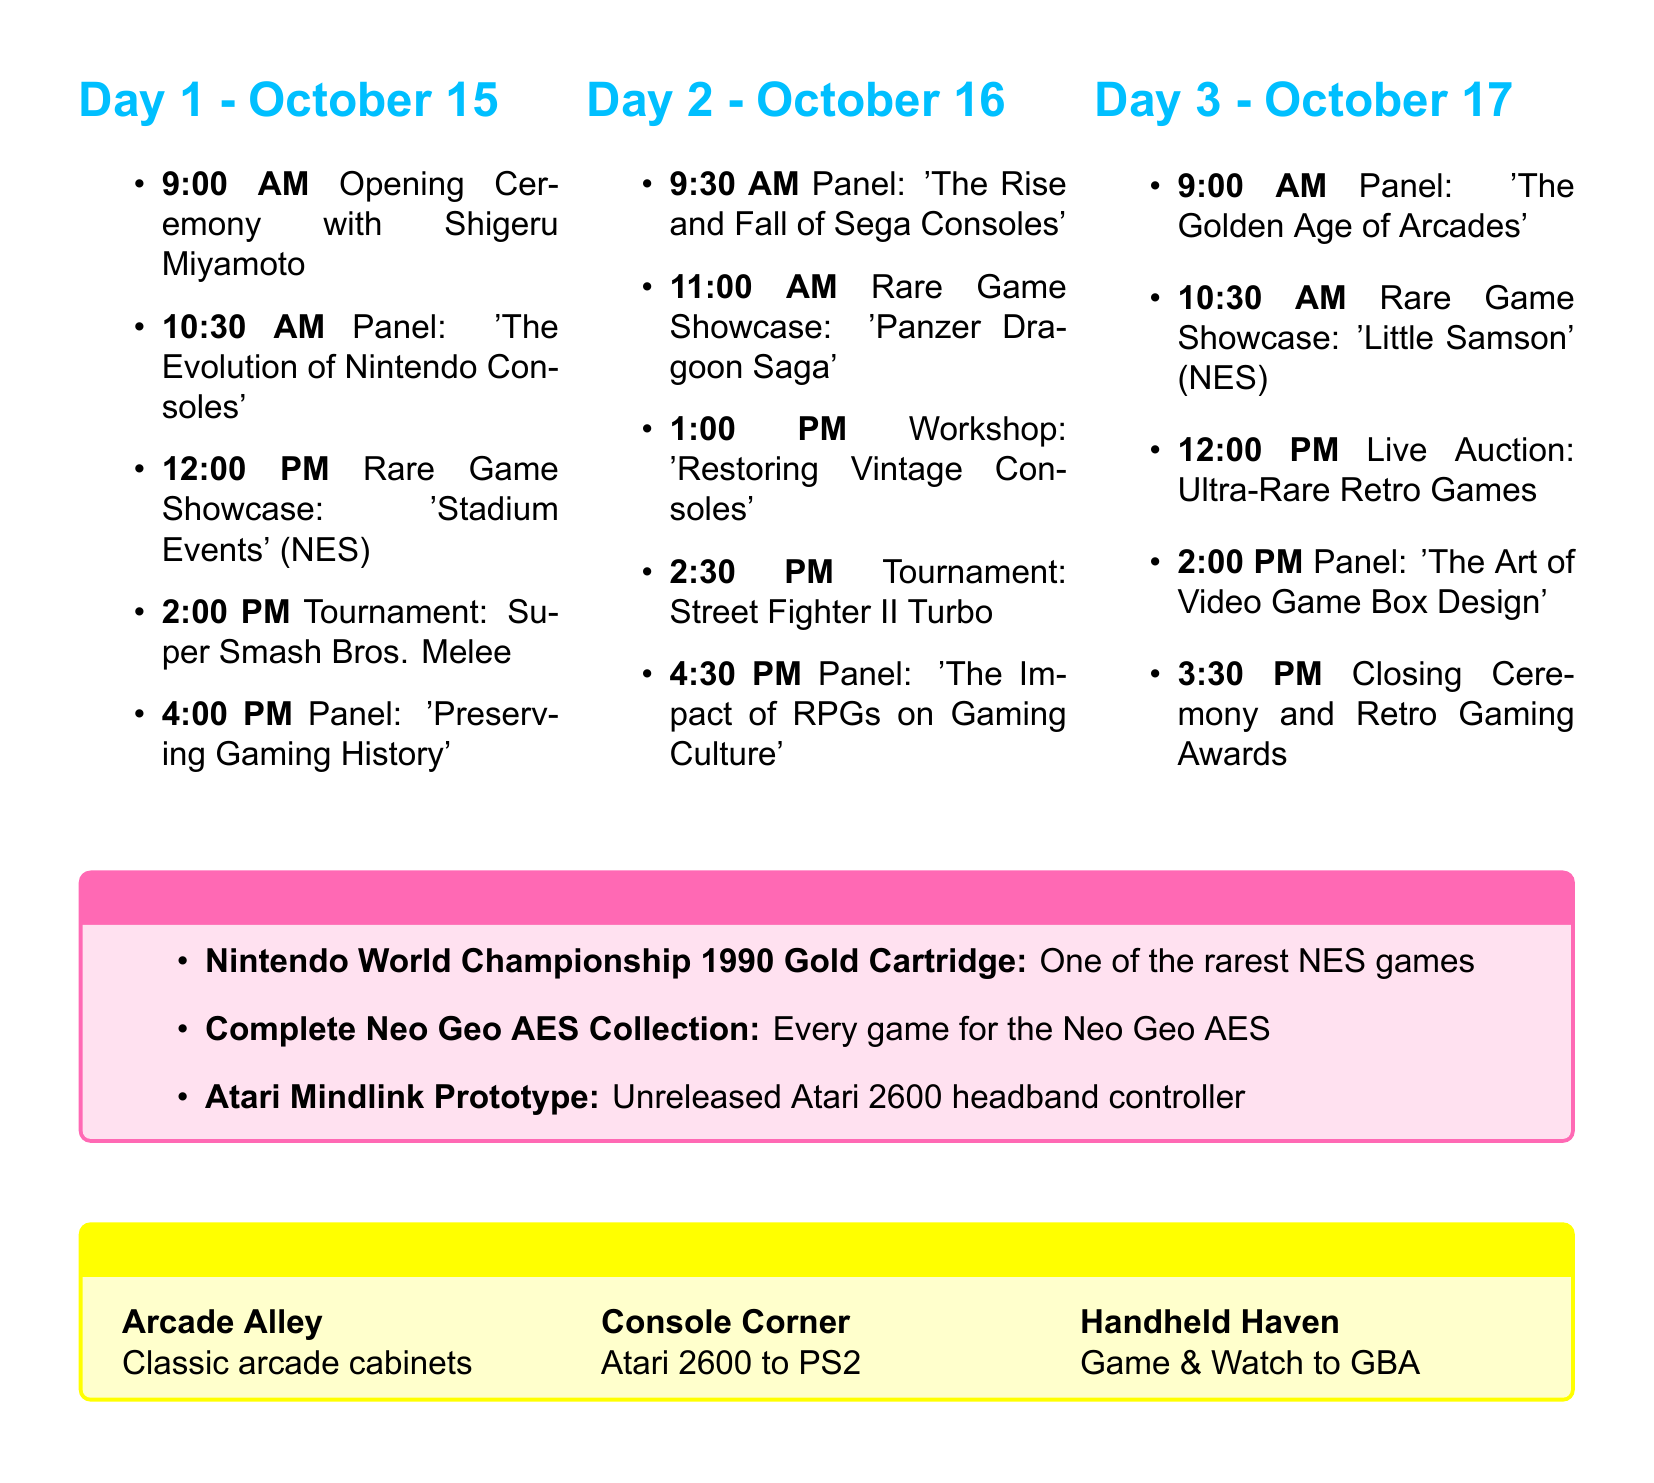What are the dates of the convention? The dates of the convention are explicitly mentioned in the document as "October 15-17, 2023."
Answer: October 15-17, 2023 Who is the special guest at the opening ceremony? The document specifies that Shigeru Miyamoto is the special guest.
Answer: Shigeru Miyamoto What time does the panel on the evolution of Nintendo consoles take place? The specific time for this panel is detailed in the document as 10:30 AM - 11:30 AM.
Answer: 10:30 AM - 11:30 AM Which rare game is showcased on Day 2? The showcased game on Day 2 is mentioned as "Panzer Dragoon Saga."
Answer: Panzer Dragoon Saga What is the topic of the panel featuring Hironobu Sakaguchi? The document states that the topic is "The Impact of RPGs on Gaming Culture."
Answer: The Impact of RPGs on Gaming Culture How many days does the RetroGamer Expo last? The document indicates that the convention lasts for three days.
Answer: Three days What is the name of the workshop on Day 2? The workshop name is provided as "Restoring and Maintaining Vintage Consoles."
Answer: Restoring and Maintaining Vintage Consoles What is presented in the special exhibit regarding the Nintendo World Championship? The document describes it as "one of the rarest NES games."
Answer: one of the rarest NES games What time is the live auction on Day 3? The document lists the live auction time as 12:00 PM - 1:30 PM.
Answer: 12:00 PM - 1:30 PM 